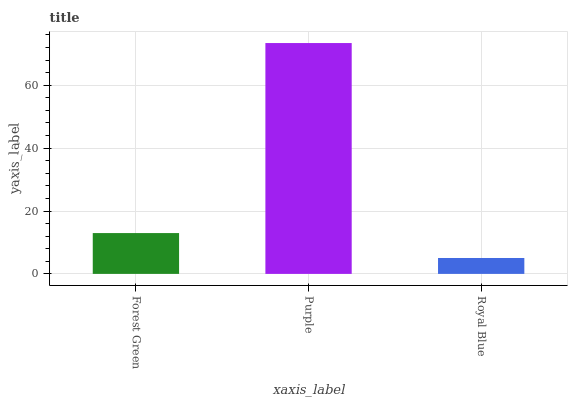Is Royal Blue the minimum?
Answer yes or no. Yes. Is Purple the maximum?
Answer yes or no. Yes. Is Purple the minimum?
Answer yes or no. No. Is Royal Blue the maximum?
Answer yes or no. No. Is Purple greater than Royal Blue?
Answer yes or no. Yes. Is Royal Blue less than Purple?
Answer yes or no. Yes. Is Royal Blue greater than Purple?
Answer yes or no. No. Is Purple less than Royal Blue?
Answer yes or no. No. Is Forest Green the high median?
Answer yes or no. Yes. Is Forest Green the low median?
Answer yes or no. Yes. Is Royal Blue the high median?
Answer yes or no. No. Is Royal Blue the low median?
Answer yes or no. No. 